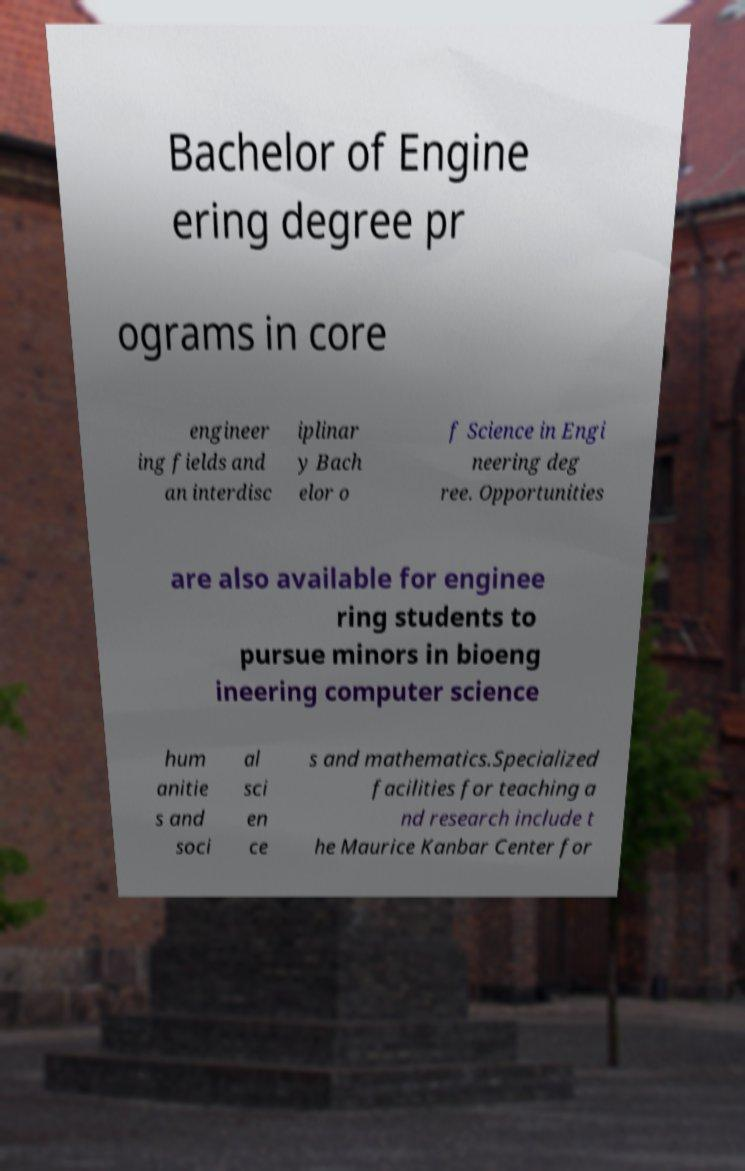Can you accurately transcribe the text from the provided image for me? Bachelor of Engine ering degree pr ograms in core engineer ing fields and an interdisc iplinar y Bach elor o f Science in Engi neering deg ree. Opportunities are also available for enginee ring students to pursue minors in bioeng ineering computer science hum anitie s and soci al sci en ce s and mathematics.Specialized facilities for teaching a nd research include t he Maurice Kanbar Center for 